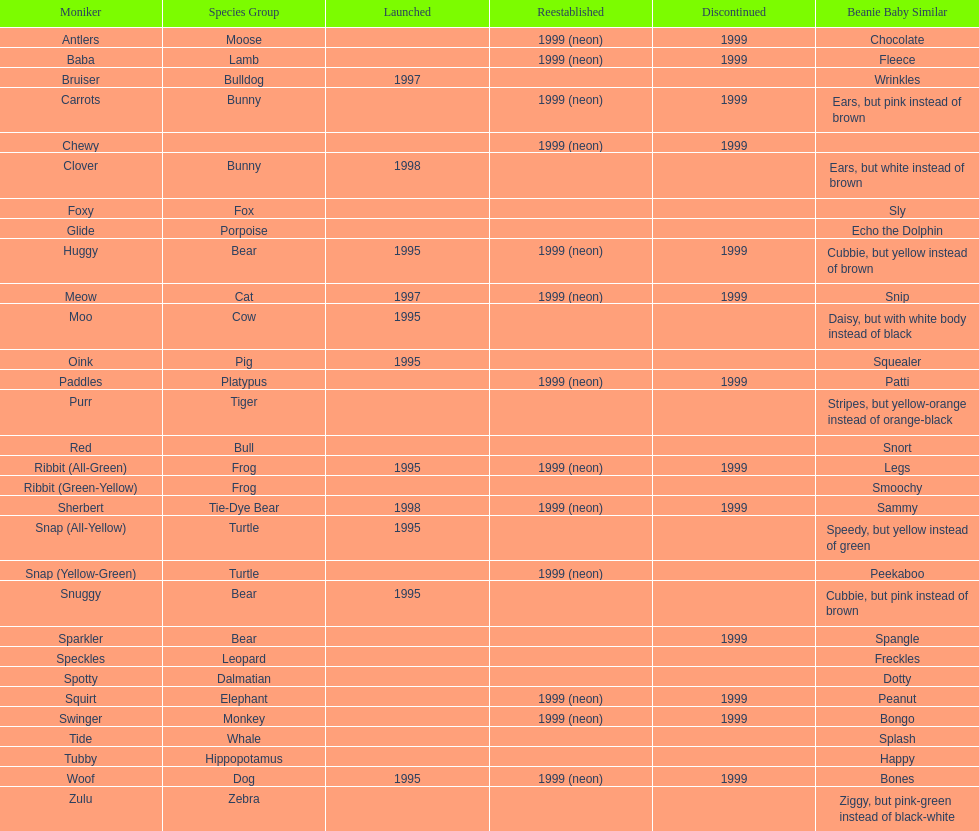Which animal type has the most pillow pals? Bear. 